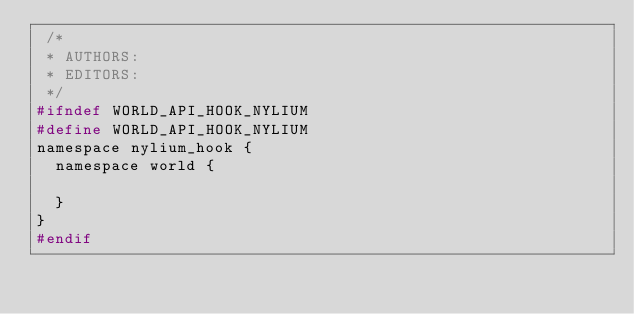<code> <loc_0><loc_0><loc_500><loc_500><_C_> /*
 * AUTHORS:
 * EDITORS:
 */
#ifndef WORLD_API_HOOK_NYLIUM
#define WORLD_API_HOOK_NYLIUM
namespace nylium_hook {
	namespace world {

	}
}
#endif</code> 